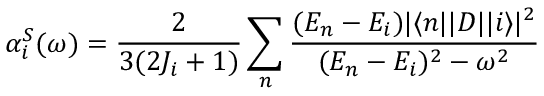<formula> <loc_0><loc_0><loc_500><loc_500>\alpha _ { i } ^ { S } ( \omega ) = \frac { 2 } { 3 ( 2 J _ { i } + 1 ) } \sum _ { n } \frac { ( E _ { n } - E _ { i } ) | \langle n | | D | | i \rangle | ^ { 2 } } { ( E _ { n } - E _ { i } ) ^ { 2 } - \omega ^ { 2 } }</formula> 